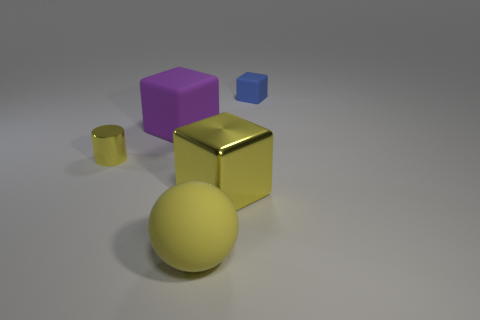Add 2 yellow matte blocks. How many objects exist? 7 Subtract all cylinders. How many objects are left? 4 Add 3 small blue blocks. How many small blue blocks are left? 4 Add 3 yellow cubes. How many yellow cubes exist? 4 Subtract 0 cyan balls. How many objects are left? 5 Subtract all metallic things. Subtract all big yellow matte objects. How many objects are left? 2 